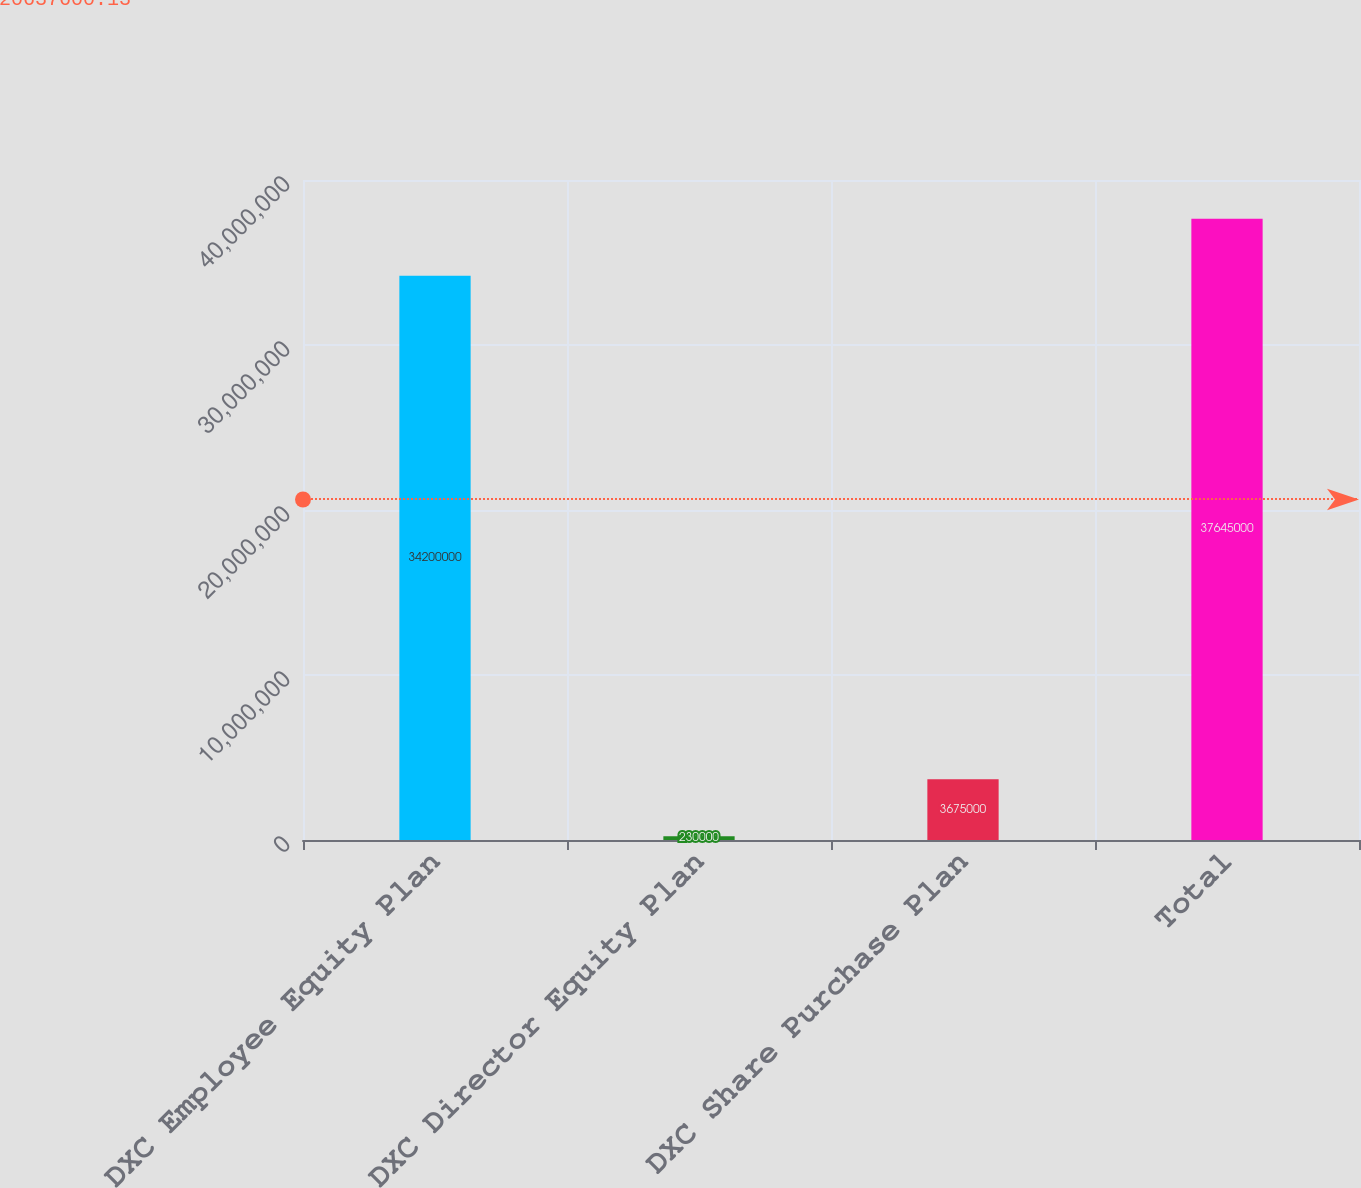Convert chart to OTSL. <chart><loc_0><loc_0><loc_500><loc_500><bar_chart><fcel>DXC Employee Equity Plan<fcel>DXC Director Equity Plan<fcel>DXC Share Purchase Plan<fcel>Total<nl><fcel>3.42e+07<fcel>230000<fcel>3.675e+06<fcel>3.7645e+07<nl></chart> 